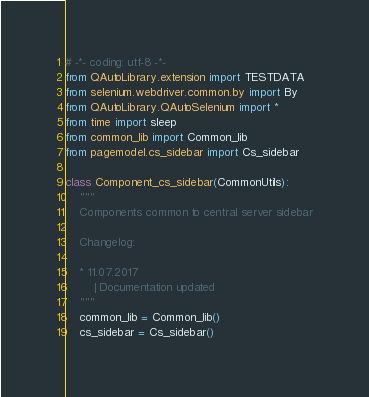Convert code to text. <code><loc_0><loc_0><loc_500><loc_500><_Python_># -*- coding: utf-8 -*-
from QAutoLibrary.extension import TESTDATA
from selenium.webdriver.common.by import By
from QAutoLibrary.QAutoSelenium import *
from time import sleep
from common_lib import Common_lib
from pagemodel.cs_sidebar import Cs_sidebar

class Component_cs_sidebar(CommonUtils):
    """
    Components common to central server sidebar

    Changelog:

    * 11.07.2017
        | Documentation updated
    """
    common_lib = Common_lib()
    cs_sidebar = Cs_sidebar()
</code> 